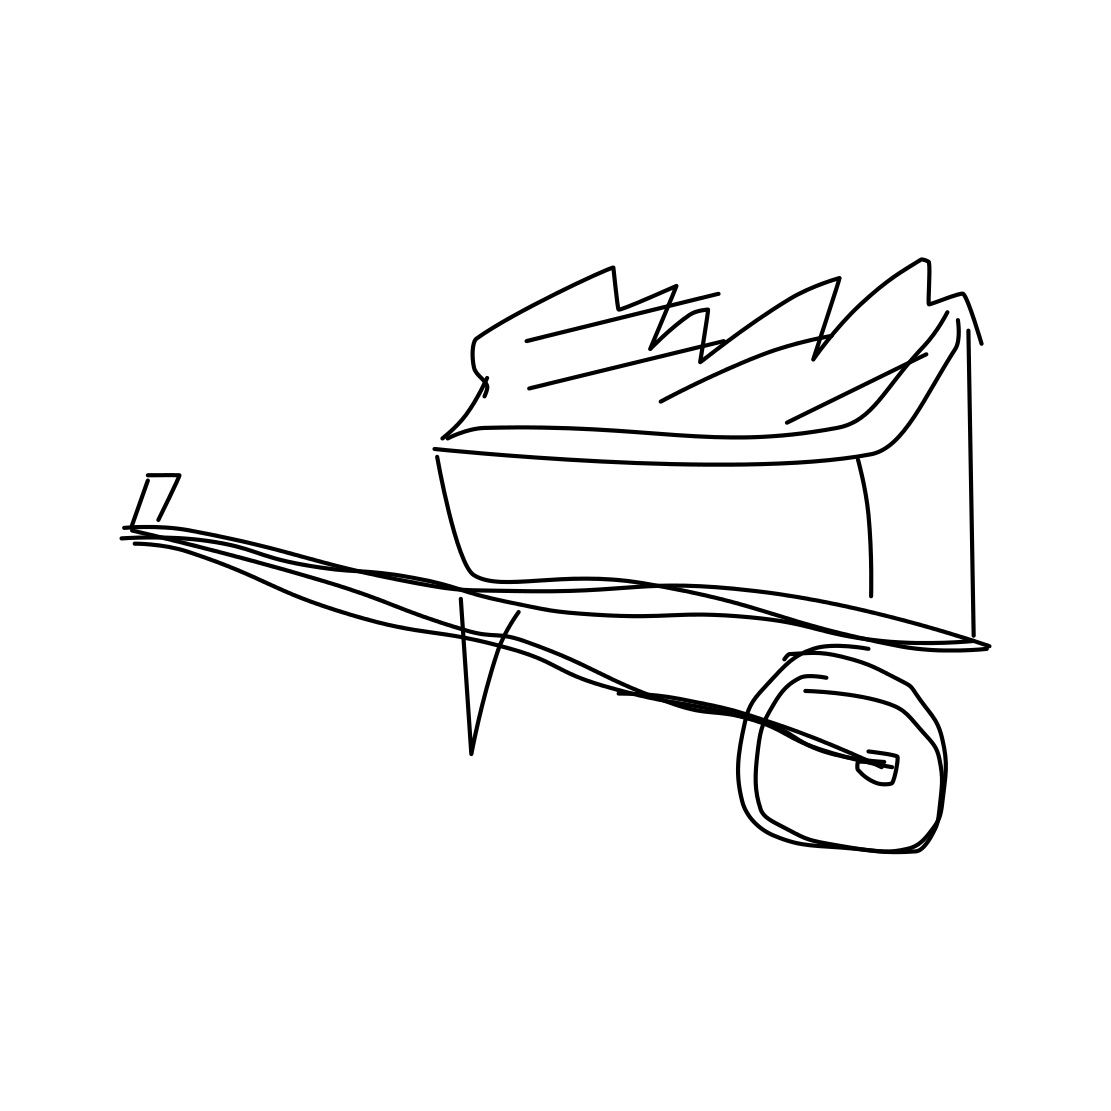In the scene, is a snowboard in it? No, there is no snowboard in the image. What you see is a bin with wheels, overflowing with what appears to be papers or trash. 